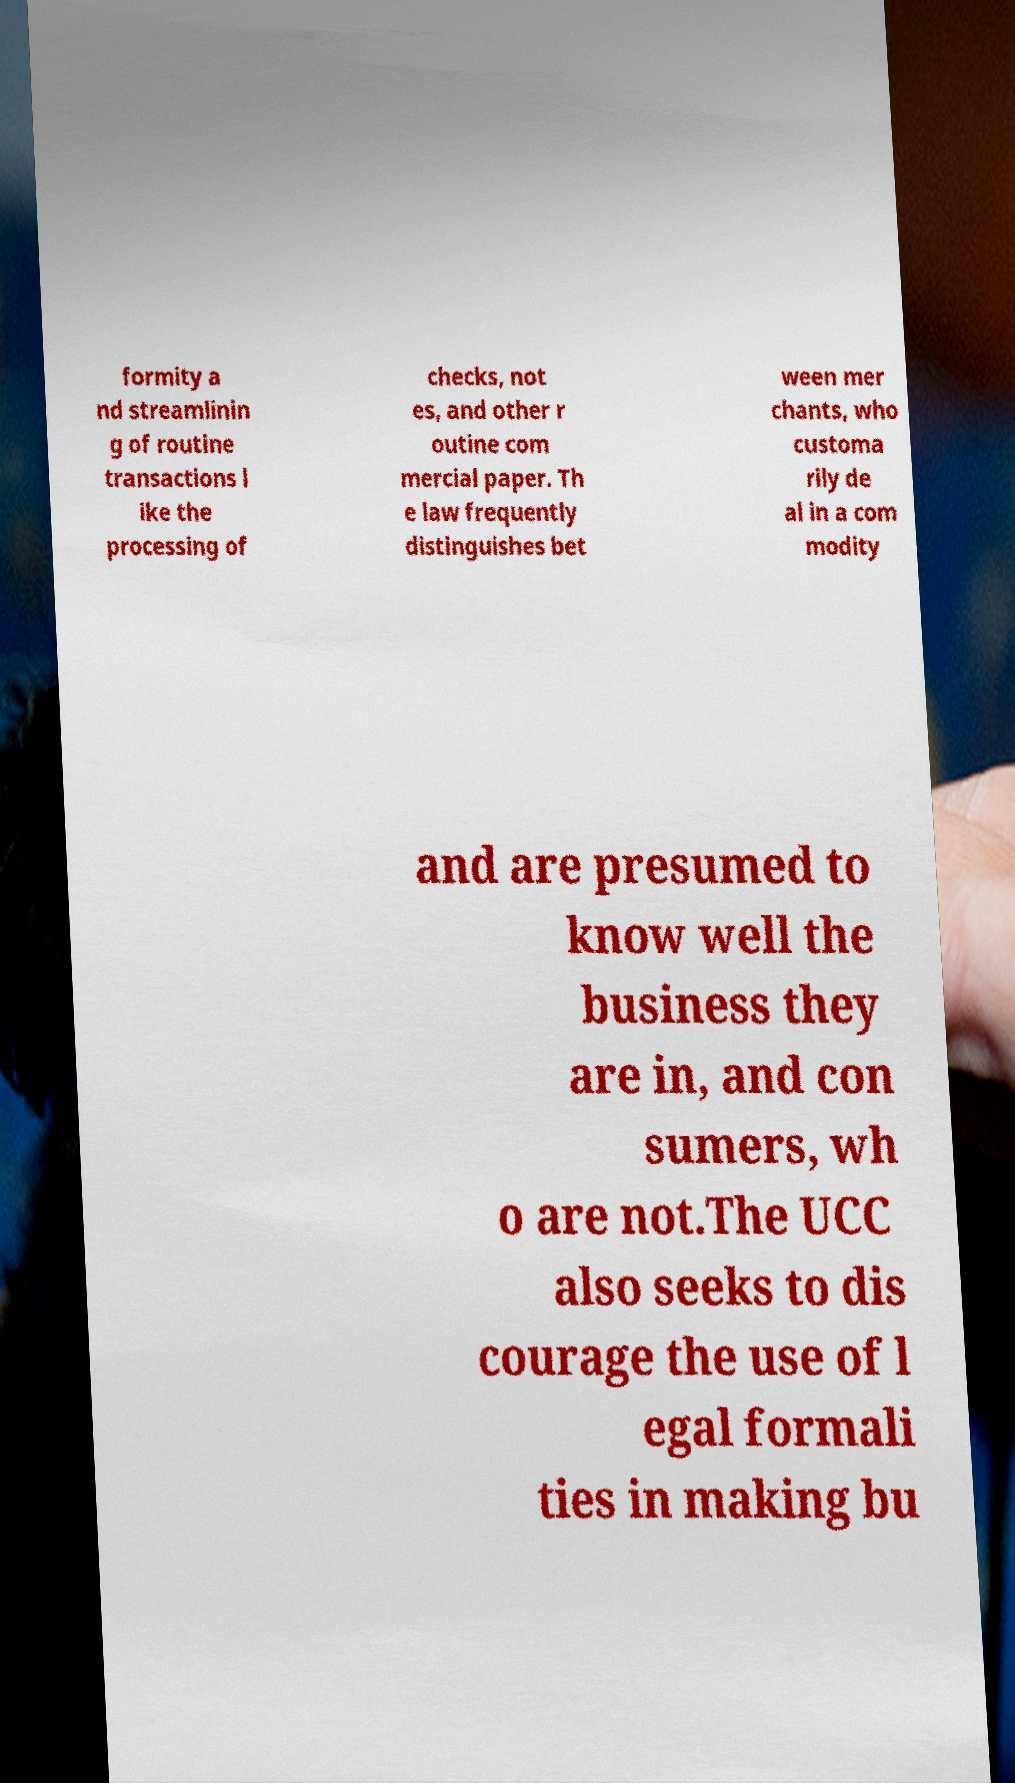Can you read and provide the text displayed in the image?This photo seems to have some interesting text. Can you extract and type it out for me? formity a nd streamlinin g of routine transactions l ike the processing of checks, not es, and other r outine com mercial paper. Th e law frequently distinguishes bet ween mer chants, who customa rily de al in a com modity and are presumed to know well the business they are in, and con sumers, wh o are not.The UCC also seeks to dis courage the use of l egal formali ties in making bu 